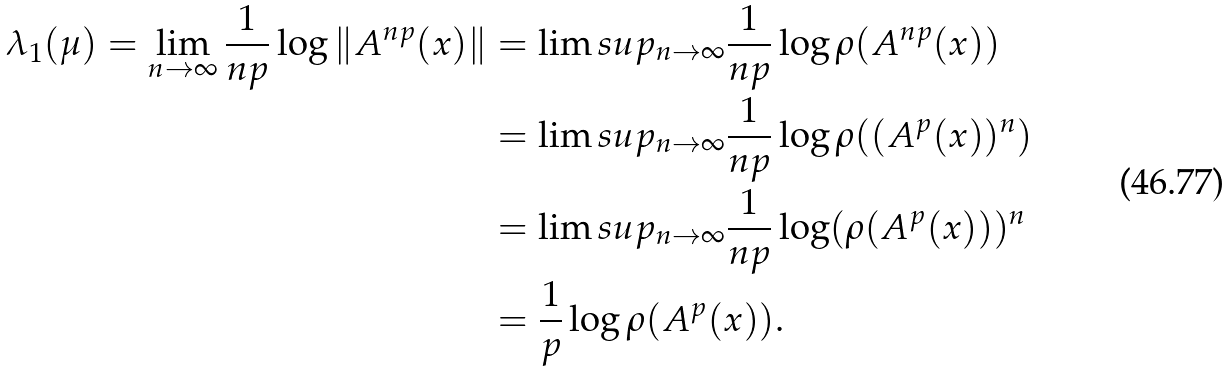Convert formula to latex. <formula><loc_0><loc_0><loc_500><loc_500>\lambda _ { 1 } ( \mu ) = \lim _ { n \to \infty } \frac { 1 } { n p } \log \| A ^ { n p } ( x ) \| & = \lim s u p _ { n \to \infty } \frac { 1 } { n p } \log \rho ( A ^ { n p } ( x ) ) \\ & = \lim s u p _ { n \to \infty } \frac { 1 } { n p } \log \rho ( ( A ^ { p } ( x ) ) ^ { n } ) \\ & = \lim s u p _ { n \to \infty } \frac { 1 } { n p } \log ( \rho ( A ^ { p } ( x ) ) ) ^ { n } \\ & = \frac { 1 } { p } \log \rho ( A ^ { p } ( x ) ) .</formula> 